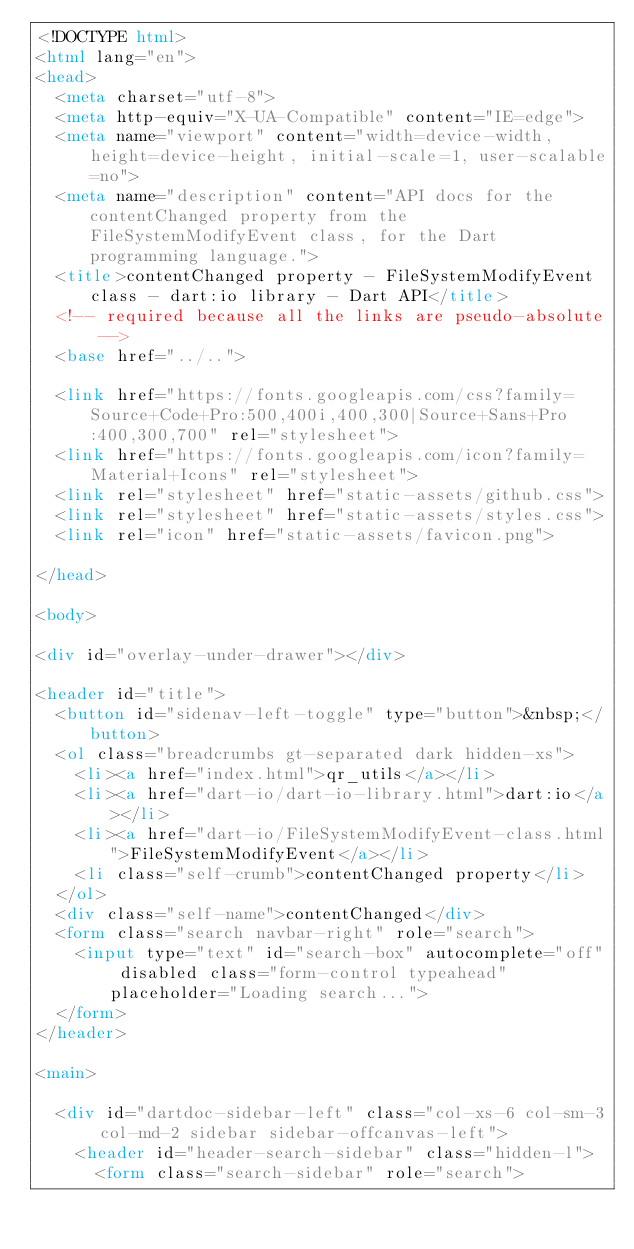<code> <loc_0><loc_0><loc_500><loc_500><_HTML_><!DOCTYPE html>
<html lang="en">
<head>
  <meta charset="utf-8">
  <meta http-equiv="X-UA-Compatible" content="IE=edge">
  <meta name="viewport" content="width=device-width, height=device-height, initial-scale=1, user-scalable=no">
  <meta name="description" content="API docs for the contentChanged property from the FileSystemModifyEvent class, for the Dart programming language.">
  <title>contentChanged property - FileSystemModifyEvent class - dart:io library - Dart API</title>
  <!-- required because all the links are pseudo-absolute -->
  <base href="../..">

  <link href="https://fonts.googleapis.com/css?family=Source+Code+Pro:500,400i,400,300|Source+Sans+Pro:400,300,700" rel="stylesheet">
  <link href="https://fonts.googleapis.com/icon?family=Material+Icons" rel="stylesheet">
  <link rel="stylesheet" href="static-assets/github.css">
  <link rel="stylesheet" href="static-assets/styles.css">
  <link rel="icon" href="static-assets/favicon.png">
  
</head>

<body>

<div id="overlay-under-drawer"></div>

<header id="title">
  <button id="sidenav-left-toggle" type="button">&nbsp;</button>
  <ol class="breadcrumbs gt-separated dark hidden-xs">
    <li><a href="index.html">qr_utils</a></li>
    <li><a href="dart-io/dart-io-library.html">dart:io</a></li>
    <li><a href="dart-io/FileSystemModifyEvent-class.html">FileSystemModifyEvent</a></li>
    <li class="self-crumb">contentChanged property</li>
  </ol>
  <div class="self-name">contentChanged</div>
  <form class="search navbar-right" role="search">
    <input type="text" id="search-box" autocomplete="off" disabled class="form-control typeahead" placeholder="Loading search...">
  </form>
</header>

<main>

  <div id="dartdoc-sidebar-left" class="col-xs-6 col-sm-3 col-md-2 sidebar sidebar-offcanvas-left">
    <header id="header-search-sidebar" class="hidden-l">
      <form class="search-sidebar" role="search"></code> 